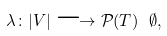Convert formula to latex. <formula><loc_0><loc_0><loc_500><loc_500>\lambda \colon | V | \longrightarrow \mathcal { P } ( T ) \ \emptyset ,</formula> 